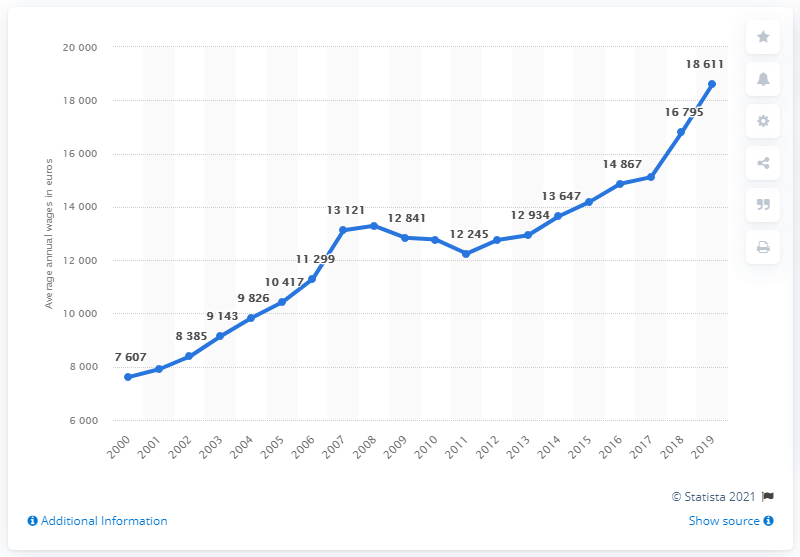Indicate a few pertinent items in this graphic. The wages reached their peak in 2019. Estonia's annual wage began to increase again in 2012. According to data from 2019, the average annual wage in Estonia was 18,611 euros. The average wage from 2017 to 2019 was 16,757.6. 